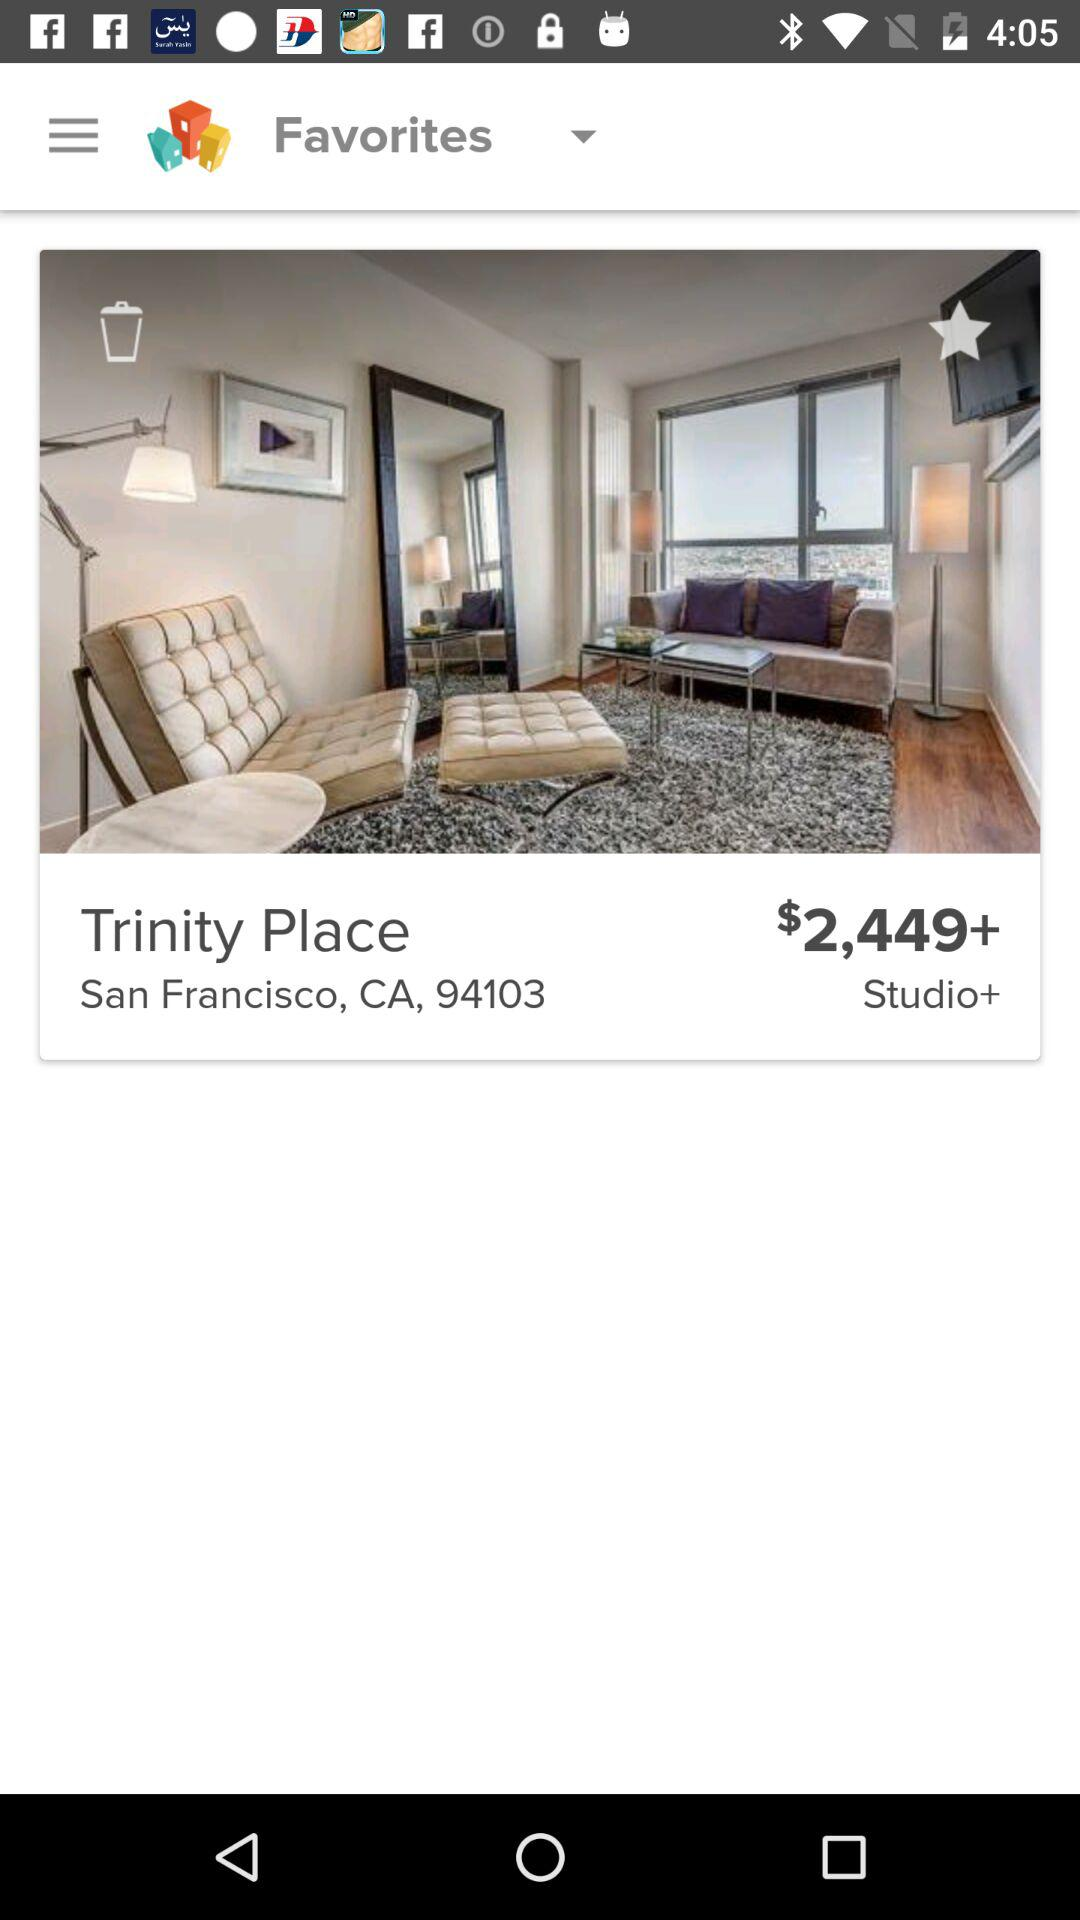What is the name of the hotel? The hotel name is Trinity Place. 